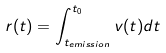<formula> <loc_0><loc_0><loc_500><loc_500>r ( t ) = \int _ { t _ { e m i s s i o n } } ^ { t _ { 0 } } v ( t ) d t</formula> 